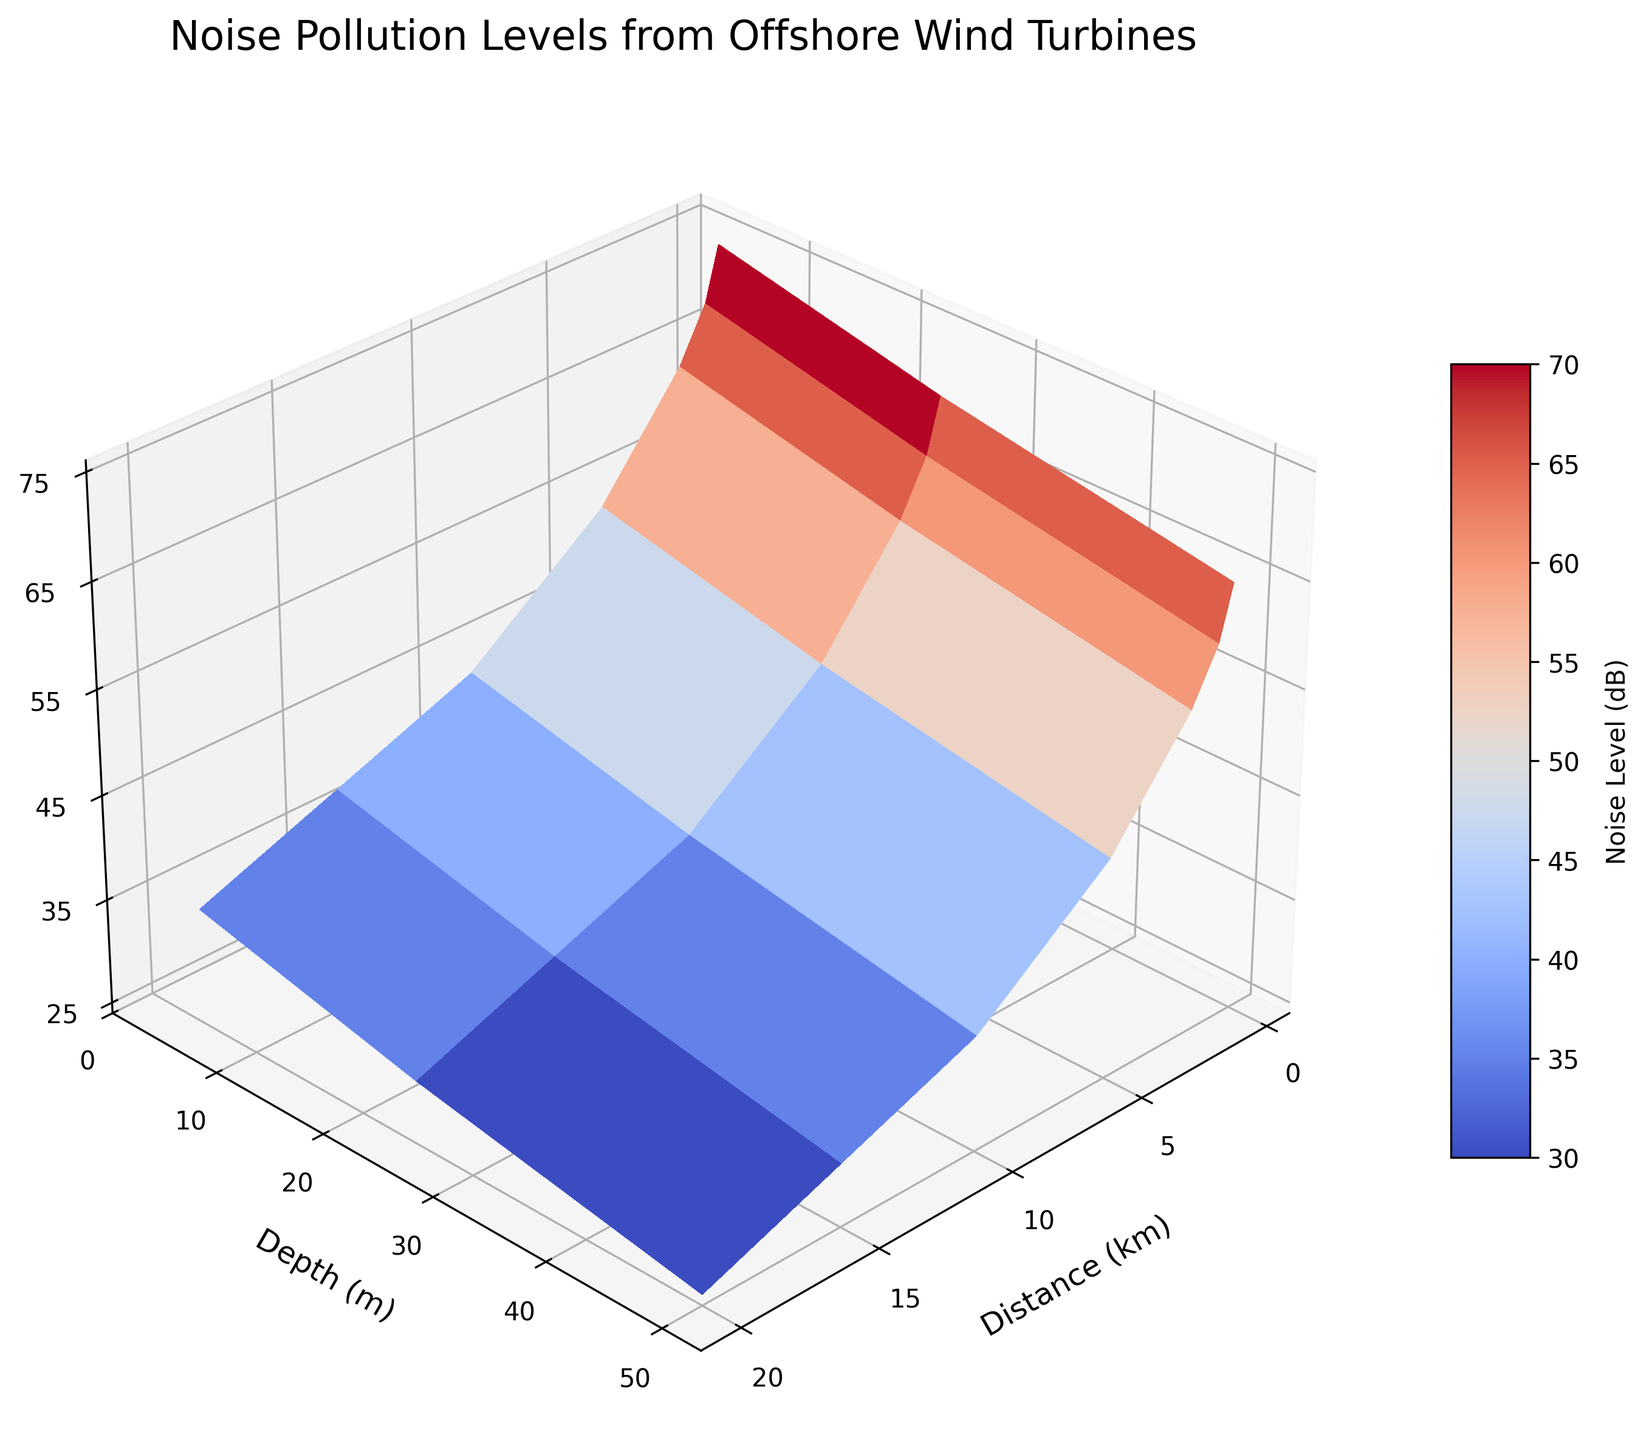What is the title of the figure? The title of the figure is displayed at the top of the plot.
Answer: Noise Pollution Levels from Offshore Wind Turbines What is the highest noise level recorded, and at which distance and depth is it observed? The highest point on the surface plot represents the maximum noise level. Find this peak and note the corresponding distance and depth on the x and y axes.
Answer: 75 dB, at 0.5 km distance and 5 m depth How does the noise level change with increasing distance at a depth of 5 meters? Follow the curve at 5 meters depth across increasing distances (x-axis) and observe the trend of the noise level (z-axis).
Answer: It decreases At which distance does the noise level drop to 45 dB at a depth of 5 meters? Locate the line corresponding to 5 meters depth and follow it until the noise level reaches 45 dB, then check the associated distance on the x-axis.
Answer: 10 km Compare the noise levels at 1 km distance for depths of 5 meters, 25 meters, and 50 meters. What do you observe? Identify the noise levels along the x-axis at 1 km distance for the specified depths and compare their values on the z-axis.
Answer: 70 dB at 5 meters, 65 dB at 25 meters, 60 dB at 50 meters What is the average noise level at a distance of 5 km, considering all depths? Note the noise levels at 5 km distance for each depth, sum them up and divide by the number of data points.
Answer: (55 + 50 + 45) / 3 = 50 dB At a depth of 25 meters, how does the noise level change as the distance increases from 0.5 km to 20 km? Follow the line at 25 meters depth along increasing distances (x-axis) and observe the trend of the noise level (z-axis).
Answer: It decreases How does the noise level at 10 km distance compare between depths of 5 and 50 meters? Look at the noise levels on the z-axis at 10 km distance for 5 meters and 50 meters depths and compare them.
Answer: Higher at 5 meters (45 dB) than at 50 meters (35 dB) What is the noise level at 15 km distance and 35-meter depth? Trace the point on the surface plot where the distance is 15 km and the depth is around 35 meters, reading off the noise level on the z-axis.
Answer: Approximately 36 dB 